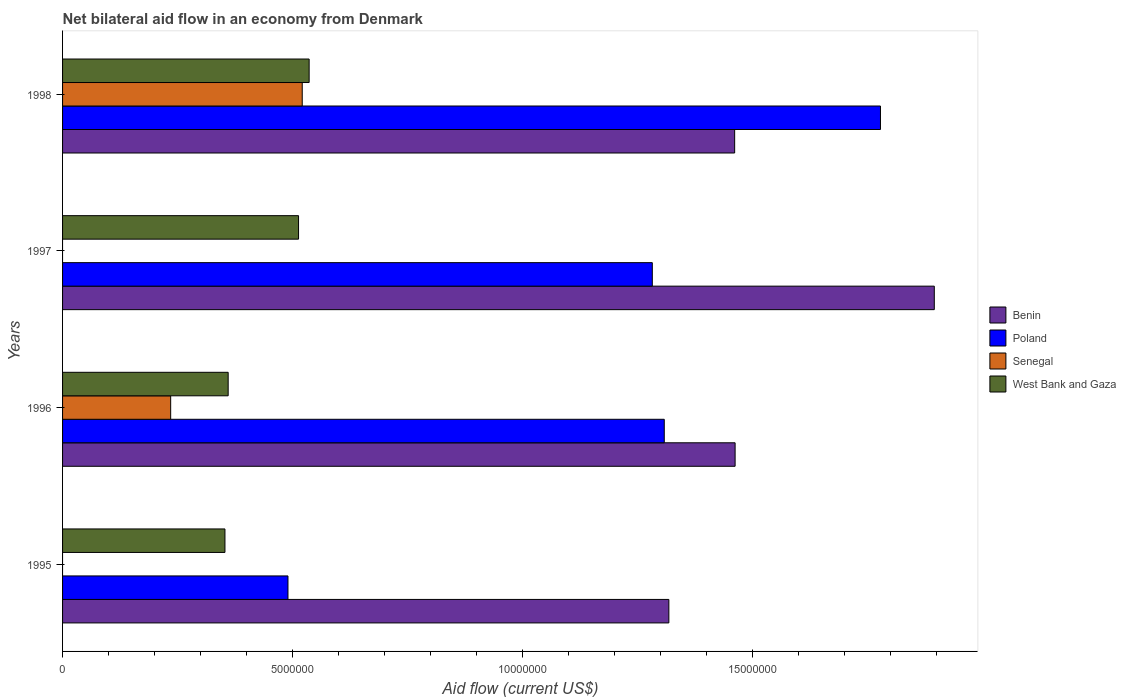How many bars are there on the 4th tick from the top?
Ensure brevity in your answer.  3. In how many cases, is the number of bars for a given year not equal to the number of legend labels?
Provide a succinct answer. 2. What is the net bilateral aid flow in Benin in 1998?
Provide a succinct answer. 1.46e+07. Across all years, what is the maximum net bilateral aid flow in Senegal?
Make the answer very short. 5.21e+06. Across all years, what is the minimum net bilateral aid flow in Benin?
Keep it short and to the point. 1.32e+07. What is the total net bilateral aid flow in West Bank and Gaza in the graph?
Your answer should be very brief. 1.76e+07. What is the difference between the net bilateral aid flow in Benin in 1995 and that in 1998?
Give a very brief answer. -1.43e+06. What is the difference between the net bilateral aid flow in Benin in 1995 and the net bilateral aid flow in Poland in 1998?
Provide a succinct answer. -4.60e+06. What is the average net bilateral aid flow in Benin per year?
Offer a terse response. 1.53e+07. In the year 1998, what is the difference between the net bilateral aid flow in Poland and net bilateral aid flow in Benin?
Give a very brief answer. 3.17e+06. In how many years, is the net bilateral aid flow in Benin greater than 3000000 US$?
Offer a very short reply. 4. What is the ratio of the net bilateral aid flow in Benin in 1996 to that in 1998?
Give a very brief answer. 1. What is the difference between the highest and the second highest net bilateral aid flow in West Bank and Gaza?
Your response must be concise. 2.30e+05. What is the difference between the highest and the lowest net bilateral aid flow in Senegal?
Your answer should be compact. 5.21e+06. In how many years, is the net bilateral aid flow in West Bank and Gaza greater than the average net bilateral aid flow in West Bank and Gaza taken over all years?
Offer a terse response. 2. Is it the case that in every year, the sum of the net bilateral aid flow in Poland and net bilateral aid flow in Benin is greater than the net bilateral aid flow in Senegal?
Your answer should be very brief. Yes. Are all the bars in the graph horizontal?
Your answer should be very brief. Yes. Are the values on the major ticks of X-axis written in scientific E-notation?
Give a very brief answer. No. Does the graph contain grids?
Provide a short and direct response. No. Where does the legend appear in the graph?
Your response must be concise. Center right. What is the title of the graph?
Give a very brief answer. Net bilateral aid flow in an economy from Denmark. Does "El Salvador" appear as one of the legend labels in the graph?
Offer a very short reply. No. What is the Aid flow (current US$) in Benin in 1995?
Keep it short and to the point. 1.32e+07. What is the Aid flow (current US$) in Poland in 1995?
Ensure brevity in your answer.  4.90e+06. What is the Aid flow (current US$) of Senegal in 1995?
Provide a short and direct response. 0. What is the Aid flow (current US$) of West Bank and Gaza in 1995?
Offer a terse response. 3.53e+06. What is the Aid flow (current US$) of Benin in 1996?
Keep it short and to the point. 1.46e+07. What is the Aid flow (current US$) in Poland in 1996?
Offer a terse response. 1.31e+07. What is the Aid flow (current US$) in Senegal in 1996?
Provide a short and direct response. 2.35e+06. What is the Aid flow (current US$) of West Bank and Gaza in 1996?
Keep it short and to the point. 3.60e+06. What is the Aid flow (current US$) in Benin in 1997?
Offer a very short reply. 1.90e+07. What is the Aid flow (current US$) in Poland in 1997?
Your answer should be compact. 1.28e+07. What is the Aid flow (current US$) of Senegal in 1997?
Offer a terse response. 0. What is the Aid flow (current US$) of West Bank and Gaza in 1997?
Offer a terse response. 5.13e+06. What is the Aid flow (current US$) of Benin in 1998?
Your answer should be very brief. 1.46e+07. What is the Aid flow (current US$) of Poland in 1998?
Ensure brevity in your answer.  1.78e+07. What is the Aid flow (current US$) of Senegal in 1998?
Offer a very short reply. 5.21e+06. What is the Aid flow (current US$) in West Bank and Gaza in 1998?
Your answer should be very brief. 5.36e+06. Across all years, what is the maximum Aid flow (current US$) in Benin?
Give a very brief answer. 1.90e+07. Across all years, what is the maximum Aid flow (current US$) of Poland?
Make the answer very short. 1.78e+07. Across all years, what is the maximum Aid flow (current US$) of Senegal?
Your response must be concise. 5.21e+06. Across all years, what is the maximum Aid flow (current US$) in West Bank and Gaza?
Give a very brief answer. 5.36e+06. Across all years, what is the minimum Aid flow (current US$) in Benin?
Offer a very short reply. 1.32e+07. Across all years, what is the minimum Aid flow (current US$) of Poland?
Provide a succinct answer. 4.90e+06. Across all years, what is the minimum Aid flow (current US$) in Senegal?
Provide a short and direct response. 0. Across all years, what is the minimum Aid flow (current US$) of West Bank and Gaza?
Offer a terse response. 3.53e+06. What is the total Aid flow (current US$) in Benin in the graph?
Your response must be concise. 6.14e+07. What is the total Aid flow (current US$) of Poland in the graph?
Give a very brief answer. 4.86e+07. What is the total Aid flow (current US$) of Senegal in the graph?
Provide a short and direct response. 7.56e+06. What is the total Aid flow (current US$) in West Bank and Gaza in the graph?
Keep it short and to the point. 1.76e+07. What is the difference between the Aid flow (current US$) of Benin in 1995 and that in 1996?
Provide a succinct answer. -1.44e+06. What is the difference between the Aid flow (current US$) of Poland in 1995 and that in 1996?
Offer a very short reply. -8.18e+06. What is the difference between the Aid flow (current US$) in West Bank and Gaza in 1995 and that in 1996?
Provide a short and direct response. -7.00e+04. What is the difference between the Aid flow (current US$) in Benin in 1995 and that in 1997?
Ensure brevity in your answer.  -5.77e+06. What is the difference between the Aid flow (current US$) in Poland in 1995 and that in 1997?
Your answer should be compact. -7.92e+06. What is the difference between the Aid flow (current US$) in West Bank and Gaza in 1995 and that in 1997?
Make the answer very short. -1.60e+06. What is the difference between the Aid flow (current US$) of Benin in 1995 and that in 1998?
Give a very brief answer. -1.43e+06. What is the difference between the Aid flow (current US$) of Poland in 1995 and that in 1998?
Your response must be concise. -1.29e+07. What is the difference between the Aid flow (current US$) in West Bank and Gaza in 1995 and that in 1998?
Give a very brief answer. -1.83e+06. What is the difference between the Aid flow (current US$) of Benin in 1996 and that in 1997?
Offer a very short reply. -4.33e+06. What is the difference between the Aid flow (current US$) of Poland in 1996 and that in 1997?
Give a very brief answer. 2.60e+05. What is the difference between the Aid flow (current US$) in West Bank and Gaza in 1996 and that in 1997?
Offer a terse response. -1.53e+06. What is the difference between the Aid flow (current US$) in Benin in 1996 and that in 1998?
Keep it short and to the point. 10000. What is the difference between the Aid flow (current US$) in Poland in 1996 and that in 1998?
Keep it short and to the point. -4.70e+06. What is the difference between the Aid flow (current US$) of Senegal in 1996 and that in 1998?
Your answer should be compact. -2.86e+06. What is the difference between the Aid flow (current US$) of West Bank and Gaza in 1996 and that in 1998?
Provide a succinct answer. -1.76e+06. What is the difference between the Aid flow (current US$) of Benin in 1997 and that in 1998?
Give a very brief answer. 4.34e+06. What is the difference between the Aid flow (current US$) of Poland in 1997 and that in 1998?
Your answer should be very brief. -4.96e+06. What is the difference between the Aid flow (current US$) of Benin in 1995 and the Aid flow (current US$) of Poland in 1996?
Your answer should be very brief. 1.00e+05. What is the difference between the Aid flow (current US$) in Benin in 1995 and the Aid flow (current US$) in Senegal in 1996?
Provide a succinct answer. 1.08e+07. What is the difference between the Aid flow (current US$) of Benin in 1995 and the Aid flow (current US$) of West Bank and Gaza in 1996?
Make the answer very short. 9.58e+06. What is the difference between the Aid flow (current US$) in Poland in 1995 and the Aid flow (current US$) in Senegal in 1996?
Provide a short and direct response. 2.55e+06. What is the difference between the Aid flow (current US$) of Poland in 1995 and the Aid flow (current US$) of West Bank and Gaza in 1996?
Your answer should be compact. 1.30e+06. What is the difference between the Aid flow (current US$) of Benin in 1995 and the Aid flow (current US$) of Poland in 1997?
Provide a short and direct response. 3.60e+05. What is the difference between the Aid flow (current US$) of Benin in 1995 and the Aid flow (current US$) of West Bank and Gaza in 1997?
Offer a terse response. 8.05e+06. What is the difference between the Aid flow (current US$) in Benin in 1995 and the Aid flow (current US$) in Poland in 1998?
Offer a terse response. -4.60e+06. What is the difference between the Aid flow (current US$) of Benin in 1995 and the Aid flow (current US$) of Senegal in 1998?
Provide a succinct answer. 7.97e+06. What is the difference between the Aid flow (current US$) in Benin in 1995 and the Aid flow (current US$) in West Bank and Gaza in 1998?
Your answer should be very brief. 7.82e+06. What is the difference between the Aid flow (current US$) of Poland in 1995 and the Aid flow (current US$) of Senegal in 1998?
Offer a very short reply. -3.10e+05. What is the difference between the Aid flow (current US$) in Poland in 1995 and the Aid flow (current US$) in West Bank and Gaza in 1998?
Provide a short and direct response. -4.60e+05. What is the difference between the Aid flow (current US$) of Benin in 1996 and the Aid flow (current US$) of Poland in 1997?
Keep it short and to the point. 1.80e+06. What is the difference between the Aid flow (current US$) of Benin in 1996 and the Aid flow (current US$) of West Bank and Gaza in 1997?
Keep it short and to the point. 9.49e+06. What is the difference between the Aid flow (current US$) in Poland in 1996 and the Aid flow (current US$) in West Bank and Gaza in 1997?
Make the answer very short. 7.95e+06. What is the difference between the Aid flow (current US$) of Senegal in 1996 and the Aid flow (current US$) of West Bank and Gaza in 1997?
Give a very brief answer. -2.78e+06. What is the difference between the Aid flow (current US$) in Benin in 1996 and the Aid flow (current US$) in Poland in 1998?
Provide a succinct answer. -3.16e+06. What is the difference between the Aid flow (current US$) in Benin in 1996 and the Aid flow (current US$) in Senegal in 1998?
Ensure brevity in your answer.  9.41e+06. What is the difference between the Aid flow (current US$) of Benin in 1996 and the Aid flow (current US$) of West Bank and Gaza in 1998?
Ensure brevity in your answer.  9.26e+06. What is the difference between the Aid flow (current US$) of Poland in 1996 and the Aid flow (current US$) of Senegal in 1998?
Provide a short and direct response. 7.87e+06. What is the difference between the Aid flow (current US$) in Poland in 1996 and the Aid flow (current US$) in West Bank and Gaza in 1998?
Your answer should be compact. 7.72e+06. What is the difference between the Aid flow (current US$) of Senegal in 1996 and the Aid flow (current US$) of West Bank and Gaza in 1998?
Ensure brevity in your answer.  -3.01e+06. What is the difference between the Aid flow (current US$) in Benin in 1997 and the Aid flow (current US$) in Poland in 1998?
Provide a short and direct response. 1.17e+06. What is the difference between the Aid flow (current US$) of Benin in 1997 and the Aid flow (current US$) of Senegal in 1998?
Your answer should be very brief. 1.37e+07. What is the difference between the Aid flow (current US$) of Benin in 1997 and the Aid flow (current US$) of West Bank and Gaza in 1998?
Give a very brief answer. 1.36e+07. What is the difference between the Aid flow (current US$) of Poland in 1997 and the Aid flow (current US$) of Senegal in 1998?
Offer a terse response. 7.61e+06. What is the difference between the Aid flow (current US$) in Poland in 1997 and the Aid flow (current US$) in West Bank and Gaza in 1998?
Offer a terse response. 7.46e+06. What is the average Aid flow (current US$) of Benin per year?
Your response must be concise. 1.53e+07. What is the average Aid flow (current US$) of Poland per year?
Your response must be concise. 1.21e+07. What is the average Aid flow (current US$) in Senegal per year?
Offer a terse response. 1.89e+06. What is the average Aid flow (current US$) of West Bank and Gaza per year?
Provide a short and direct response. 4.40e+06. In the year 1995, what is the difference between the Aid flow (current US$) of Benin and Aid flow (current US$) of Poland?
Ensure brevity in your answer.  8.28e+06. In the year 1995, what is the difference between the Aid flow (current US$) in Benin and Aid flow (current US$) in West Bank and Gaza?
Ensure brevity in your answer.  9.65e+06. In the year 1995, what is the difference between the Aid flow (current US$) in Poland and Aid flow (current US$) in West Bank and Gaza?
Offer a terse response. 1.37e+06. In the year 1996, what is the difference between the Aid flow (current US$) of Benin and Aid flow (current US$) of Poland?
Keep it short and to the point. 1.54e+06. In the year 1996, what is the difference between the Aid flow (current US$) in Benin and Aid flow (current US$) in Senegal?
Your answer should be very brief. 1.23e+07. In the year 1996, what is the difference between the Aid flow (current US$) of Benin and Aid flow (current US$) of West Bank and Gaza?
Offer a terse response. 1.10e+07. In the year 1996, what is the difference between the Aid flow (current US$) in Poland and Aid flow (current US$) in Senegal?
Your answer should be very brief. 1.07e+07. In the year 1996, what is the difference between the Aid flow (current US$) of Poland and Aid flow (current US$) of West Bank and Gaza?
Ensure brevity in your answer.  9.48e+06. In the year 1996, what is the difference between the Aid flow (current US$) in Senegal and Aid flow (current US$) in West Bank and Gaza?
Make the answer very short. -1.25e+06. In the year 1997, what is the difference between the Aid flow (current US$) of Benin and Aid flow (current US$) of Poland?
Provide a short and direct response. 6.13e+06. In the year 1997, what is the difference between the Aid flow (current US$) in Benin and Aid flow (current US$) in West Bank and Gaza?
Give a very brief answer. 1.38e+07. In the year 1997, what is the difference between the Aid flow (current US$) of Poland and Aid flow (current US$) of West Bank and Gaza?
Offer a terse response. 7.69e+06. In the year 1998, what is the difference between the Aid flow (current US$) of Benin and Aid flow (current US$) of Poland?
Your answer should be very brief. -3.17e+06. In the year 1998, what is the difference between the Aid flow (current US$) in Benin and Aid flow (current US$) in Senegal?
Offer a terse response. 9.40e+06. In the year 1998, what is the difference between the Aid flow (current US$) of Benin and Aid flow (current US$) of West Bank and Gaza?
Your response must be concise. 9.25e+06. In the year 1998, what is the difference between the Aid flow (current US$) in Poland and Aid flow (current US$) in Senegal?
Your response must be concise. 1.26e+07. In the year 1998, what is the difference between the Aid flow (current US$) of Poland and Aid flow (current US$) of West Bank and Gaza?
Make the answer very short. 1.24e+07. In the year 1998, what is the difference between the Aid flow (current US$) in Senegal and Aid flow (current US$) in West Bank and Gaza?
Give a very brief answer. -1.50e+05. What is the ratio of the Aid flow (current US$) in Benin in 1995 to that in 1996?
Offer a terse response. 0.9. What is the ratio of the Aid flow (current US$) of Poland in 1995 to that in 1996?
Provide a succinct answer. 0.37. What is the ratio of the Aid flow (current US$) of West Bank and Gaza in 1995 to that in 1996?
Your answer should be very brief. 0.98. What is the ratio of the Aid flow (current US$) in Benin in 1995 to that in 1997?
Make the answer very short. 0.7. What is the ratio of the Aid flow (current US$) in Poland in 1995 to that in 1997?
Provide a succinct answer. 0.38. What is the ratio of the Aid flow (current US$) in West Bank and Gaza in 1995 to that in 1997?
Provide a succinct answer. 0.69. What is the ratio of the Aid flow (current US$) in Benin in 1995 to that in 1998?
Ensure brevity in your answer.  0.9. What is the ratio of the Aid flow (current US$) of Poland in 1995 to that in 1998?
Keep it short and to the point. 0.28. What is the ratio of the Aid flow (current US$) in West Bank and Gaza in 1995 to that in 1998?
Give a very brief answer. 0.66. What is the ratio of the Aid flow (current US$) in Benin in 1996 to that in 1997?
Provide a succinct answer. 0.77. What is the ratio of the Aid flow (current US$) in Poland in 1996 to that in 1997?
Give a very brief answer. 1.02. What is the ratio of the Aid flow (current US$) of West Bank and Gaza in 1996 to that in 1997?
Provide a short and direct response. 0.7. What is the ratio of the Aid flow (current US$) in Poland in 1996 to that in 1998?
Offer a terse response. 0.74. What is the ratio of the Aid flow (current US$) of Senegal in 1996 to that in 1998?
Offer a very short reply. 0.45. What is the ratio of the Aid flow (current US$) of West Bank and Gaza in 1996 to that in 1998?
Your answer should be compact. 0.67. What is the ratio of the Aid flow (current US$) in Benin in 1997 to that in 1998?
Keep it short and to the point. 1.3. What is the ratio of the Aid flow (current US$) in Poland in 1997 to that in 1998?
Provide a succinct answer. 0.72. What is the ratio of the Aid flow (current US$) of West Bank and Gaza in 1997 to that in 1998?
Keep it short and to the point. 0.96. What is the difference between the highest and the second highest Aid flow (current US$) in Benin?
Your answer should be compact. 4.33e+06. What is the difference between the highest and the second highest Aid flow (current US$) of Poland?
Offer a very short reply. 4.70e+06. What is the difference between the highest and the second highest Aid flow (current US$) in West Bank and Gaza?
Your answer should be compact. 2.30e+05. What is the difference between the highest and the lowest Aid flow (current US$) in Benin?
Give a very brief answer. 5.77e+06. What is the difference between the highest and the lowest Aid flow (current US$) of Poland?
Provide a succinct answer. 1.29e+07. What is the difference between the highest and the lowest Aid flow (current US$) in Senegal?
Your response must be concise. 5.21e+06. What is the difference between the highest and the lowest Aid flow (current US$) in West Bank and Gaza?
Make the answer very short. 1.83e+06. 